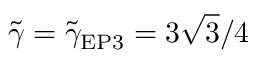<formula> <loc_0><loc_0><loc_500><loc_500>\tilde { \gamma } = \tilde { \gamma } _ { E P 3 } = 3 \sqrt { 3 } / 4</formula> 